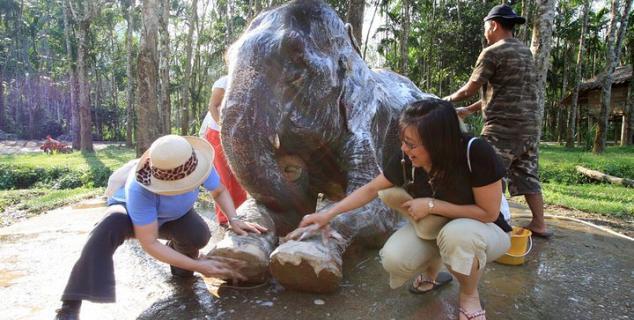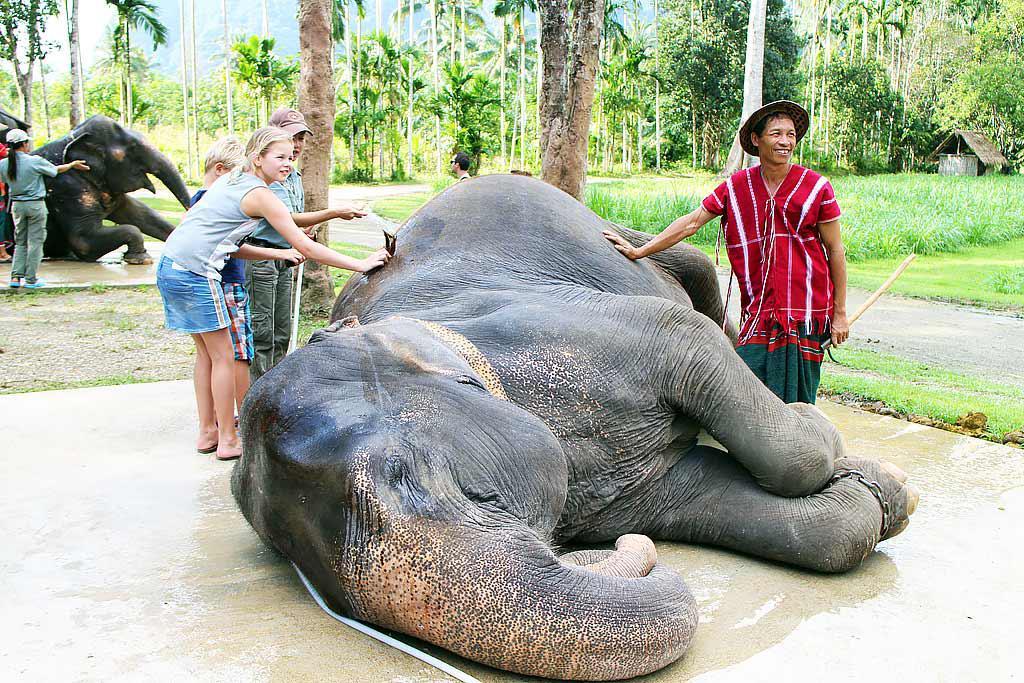The first image is the image on the left, the second image is the image on the right. Examine the images to the left and right. Is the description "There are no more than 4 elephants in the image pair" accurate? Answer yes or no. Yes. The first image is the image on the left, the second image is the image on the right. Examine the images to the left and right. Is the description "There are at least six elephants." accurate? Answer yes or no. No. 